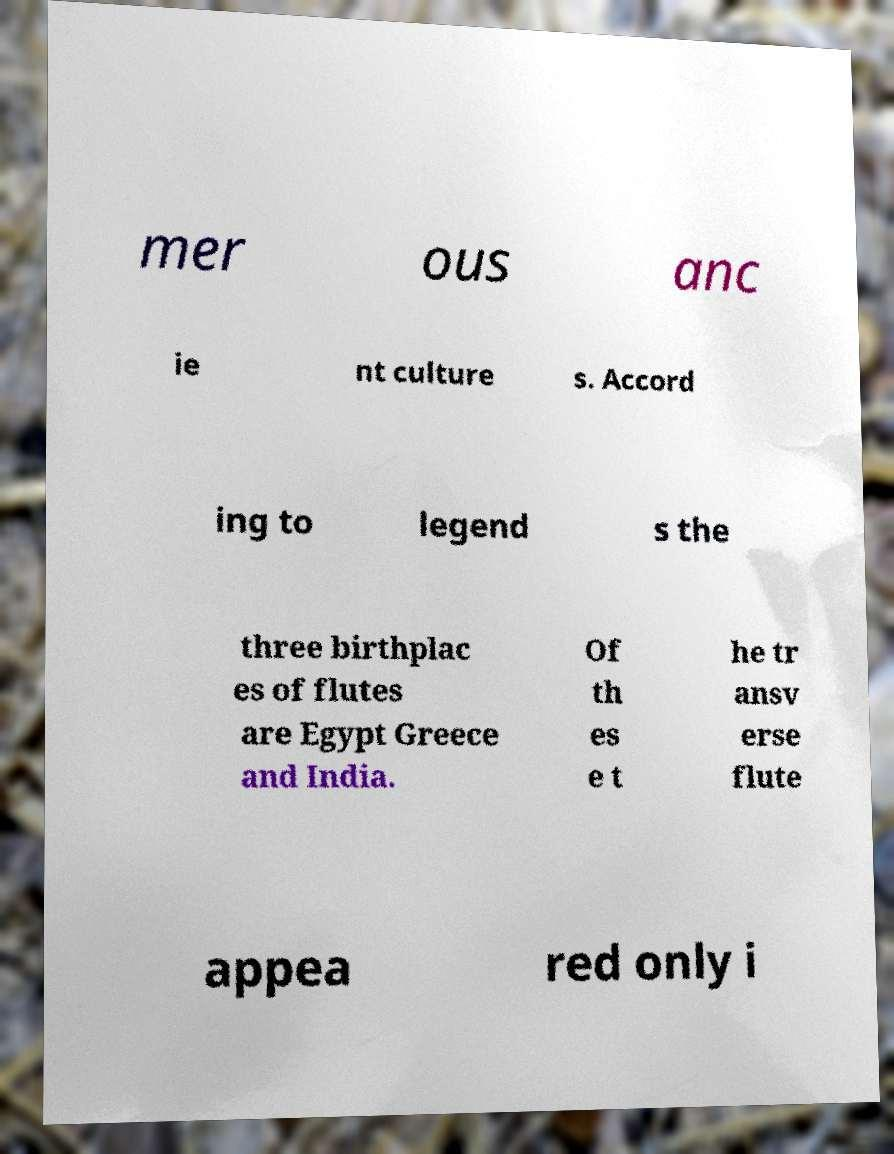For documentation purposes, I need the text within this image transcribed. Could you provide that? mer ous anc ie nt culture s. Accord ing to legend s the three birthplac es of flutes are Egypt Greece and India. Of th es e t he tr ansv erse flute appea red only i 